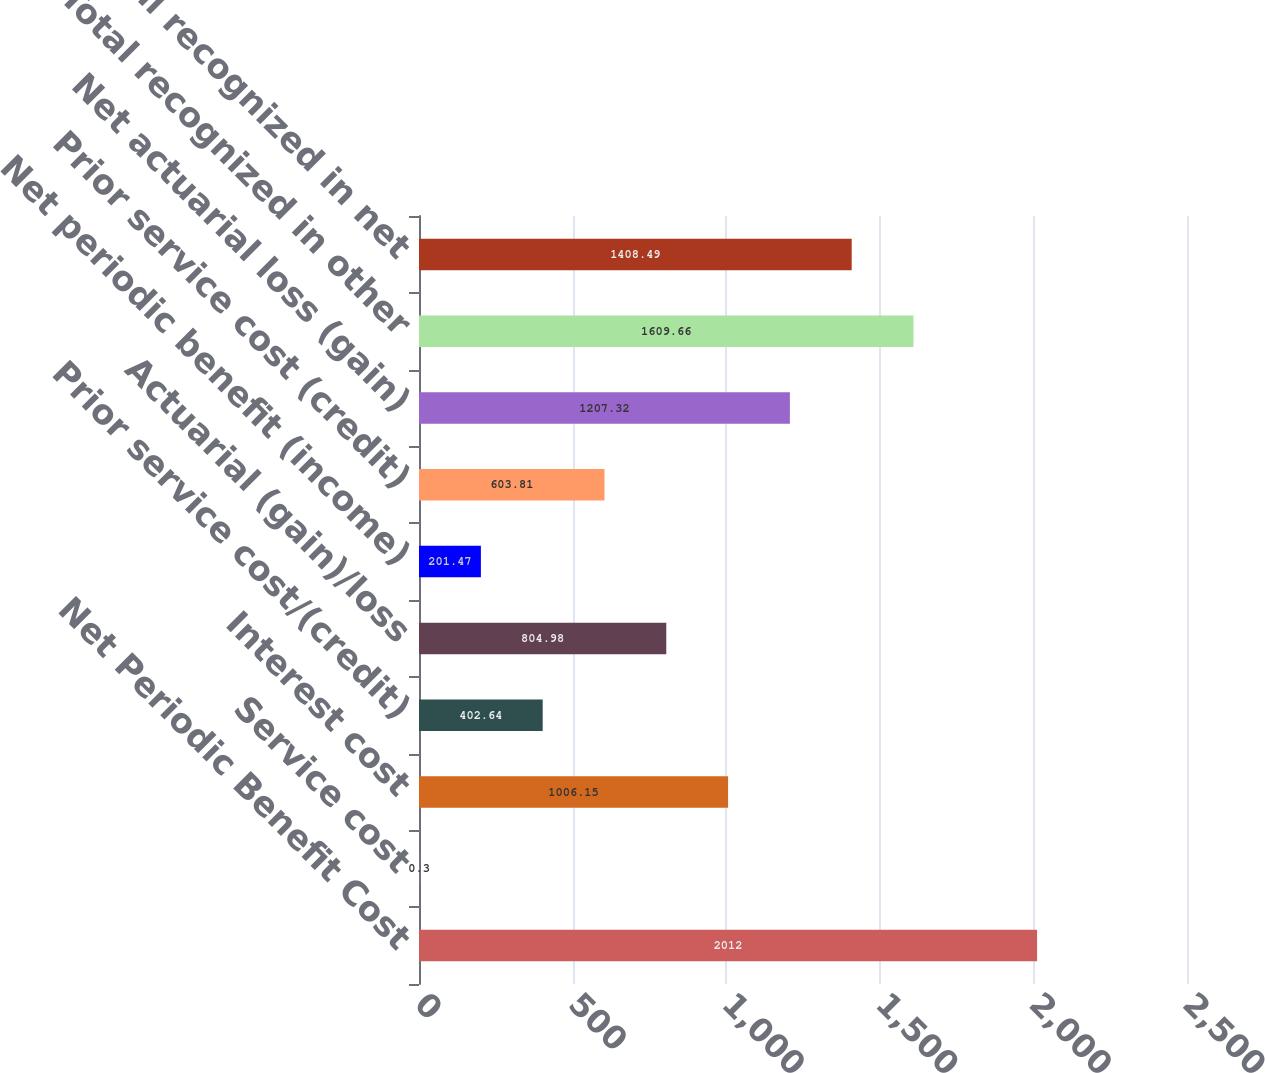Convert chart. <chart><loc_0><loc_0><loc_500><loc_500><bar_chart><fcel>Net Periodic Benefit Cost<fcel>Service cost<fcel>Interest cost<fcel>Prior service cost/(credit)<fcel>Actuarial (gain)/loss<fcel>Net periodic benefit (income)<fcel>Prior service cost (credit)<fcel>Net actuarial loss (gain)<fcel>Total recognized in other<fcel>Total recognized in net<nl><fcel>2012<fcel>0.3<fcel>1006.15<fcel>402.64<fcel>804.98<fcel>201.47<fcel>603.81<fcel>1207.32<fcel>1609.66<fcel>1408.49<nl></chart> 